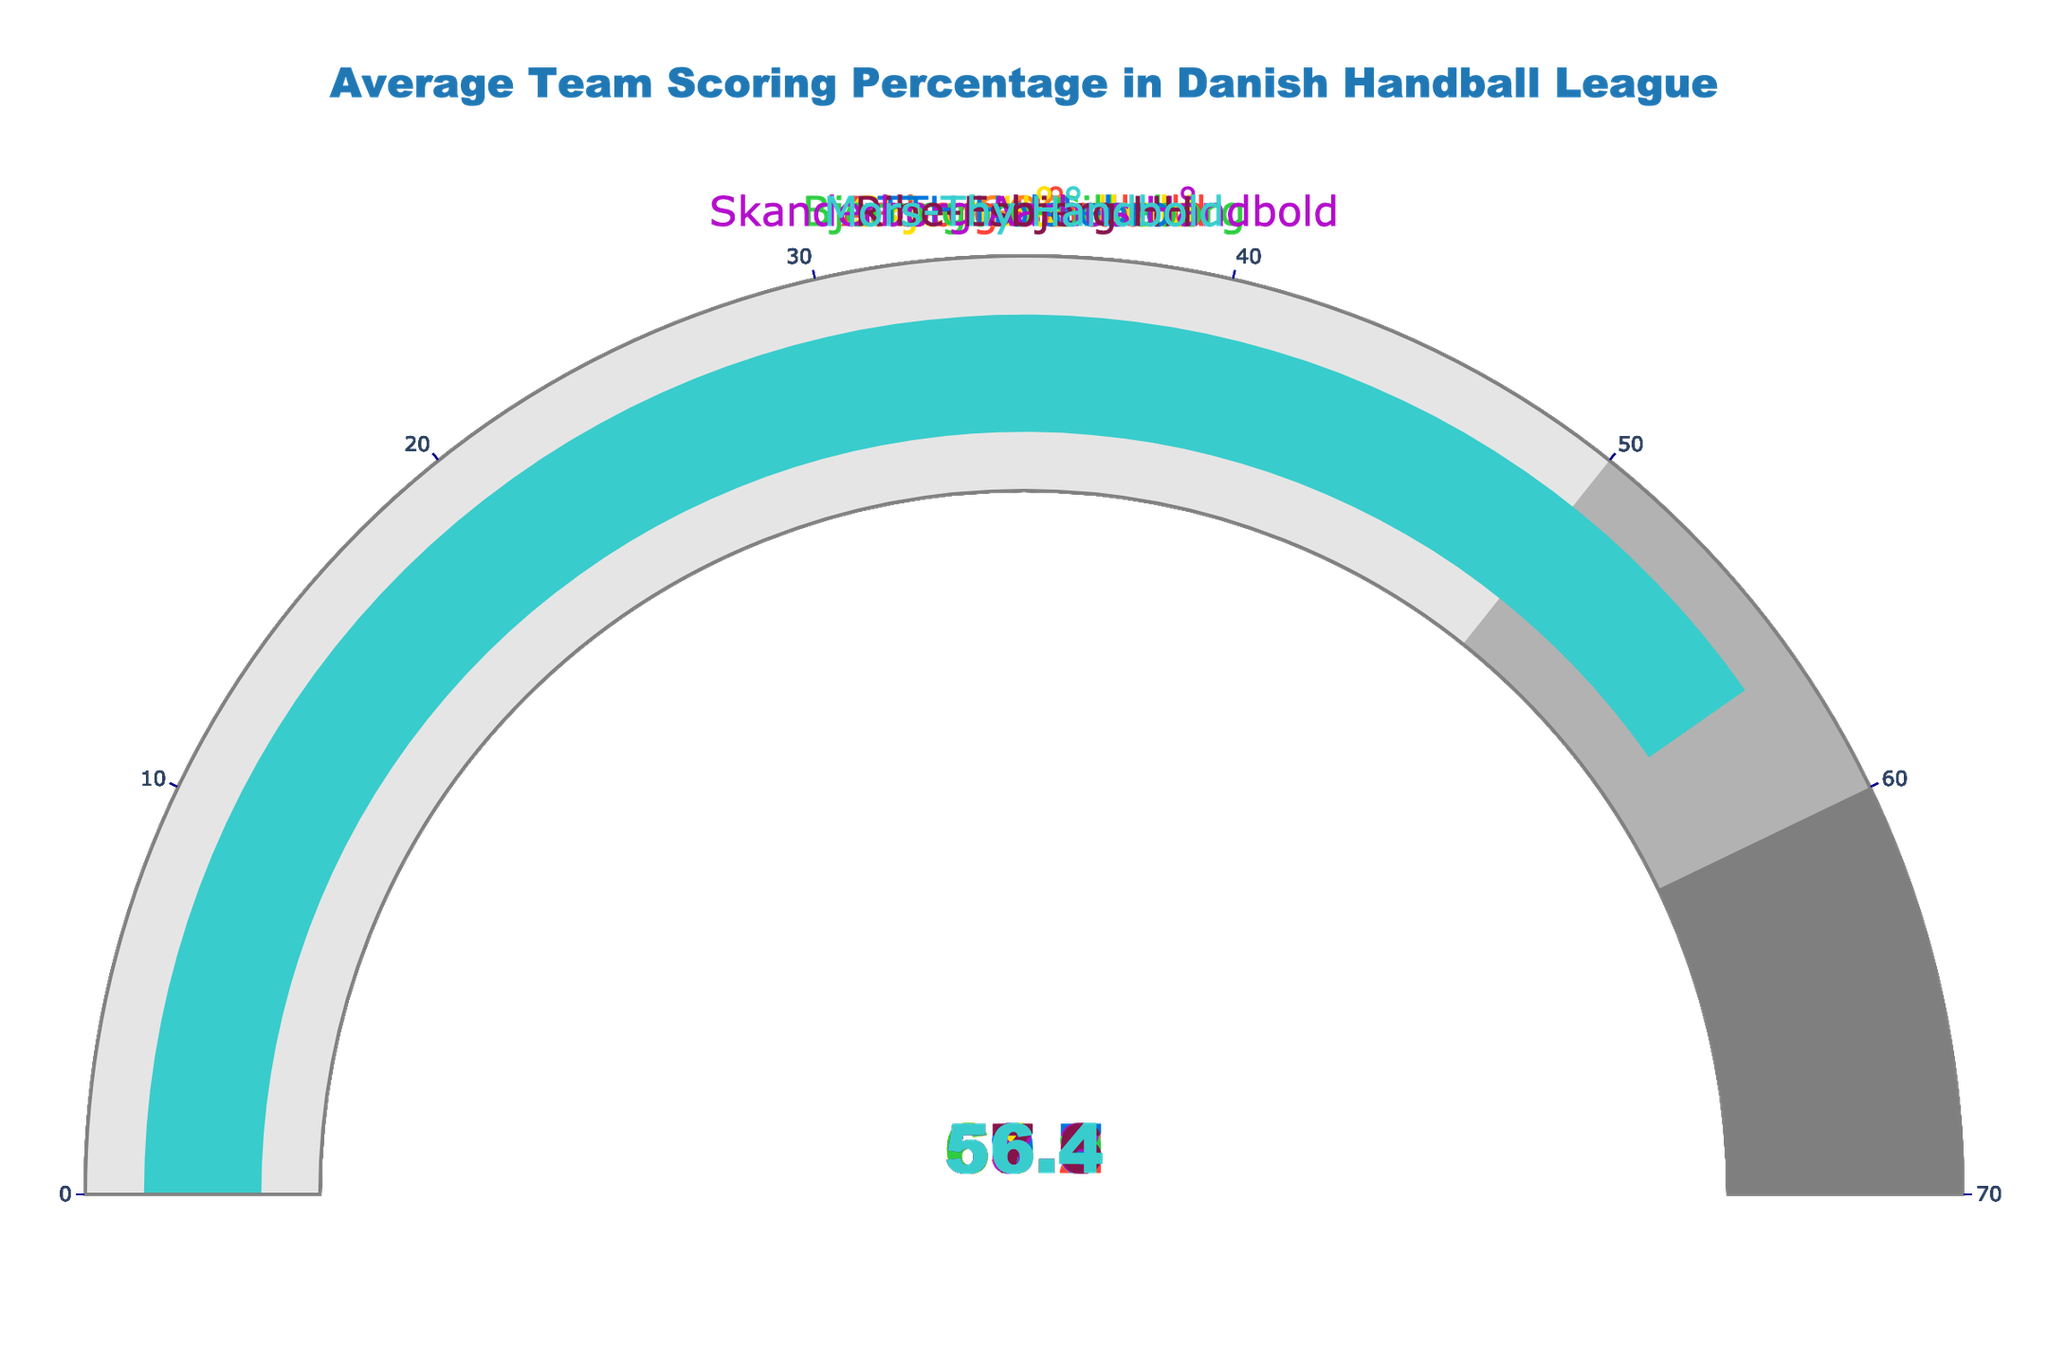what is the highest team scoring percentage shown in the figure? To find the highest team scoring percentage, look for the gauge with the highest value displayed.
Answer: 65.2% what is the difference in scoring percentage between Aalborg Håndbold and GOG? Look at the values shown for both teams: Aalborg Håndbold is 65.2% and GOG is 63.8%. Subtract 63.8% from 65.2%.
Answer: 1.4% Which team has the lowest scoring percentage? Identify the gauge with the lowest percentage value displayed.
Answer: Mors-Thy Håndbold What is the average scoring percentage of the teams shown in the figure? Sum all the scoring percentages and divide by the number of teams. (65.2 + 63.8 + 61.5 + 60.9 + 59.7 + 58.3 + 57.6 + 56.4) / 8 = 59.675
Answer: 59.675% How many teams have a scoring percentage above 60%? Count the number of gauges with values above 60%.
Answer: 4 